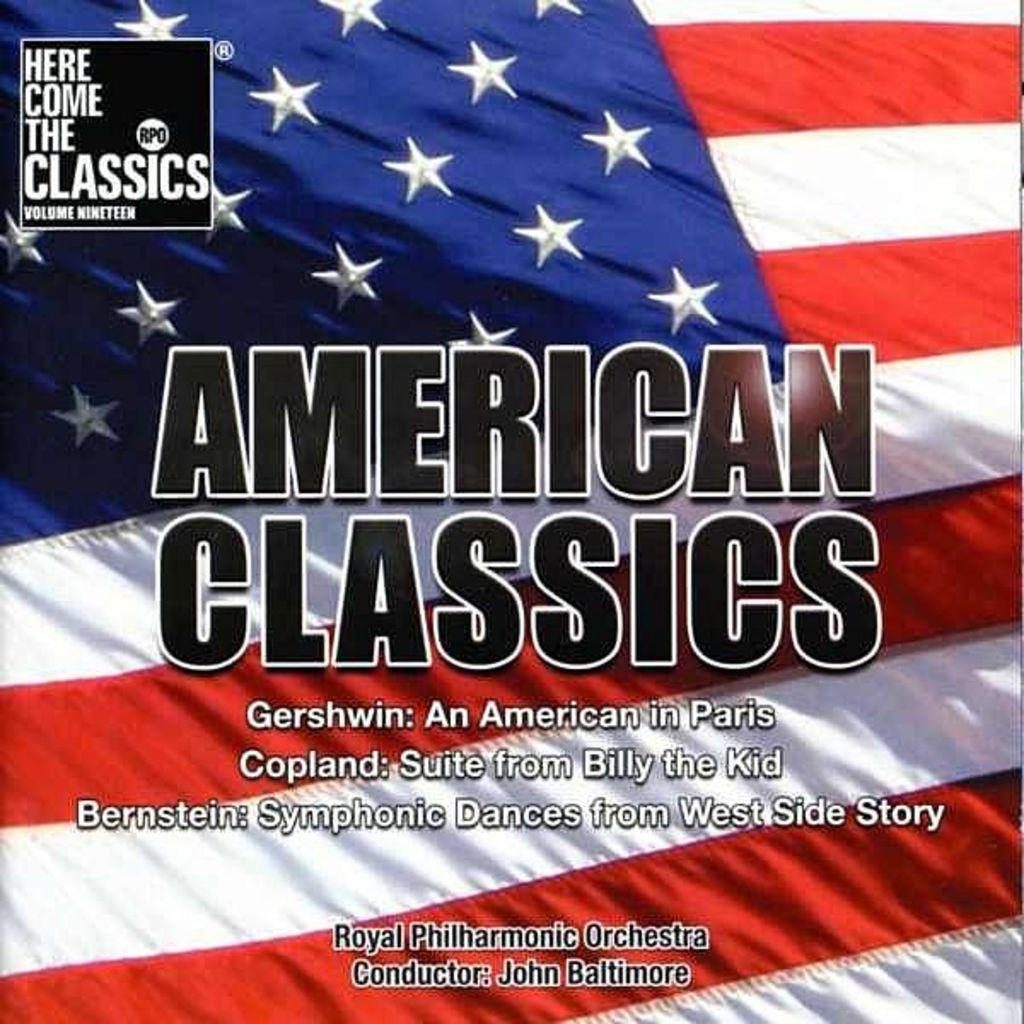Please provide a concise description of this image. This image consists of a poster with an image of a flag and there is a text on it. 